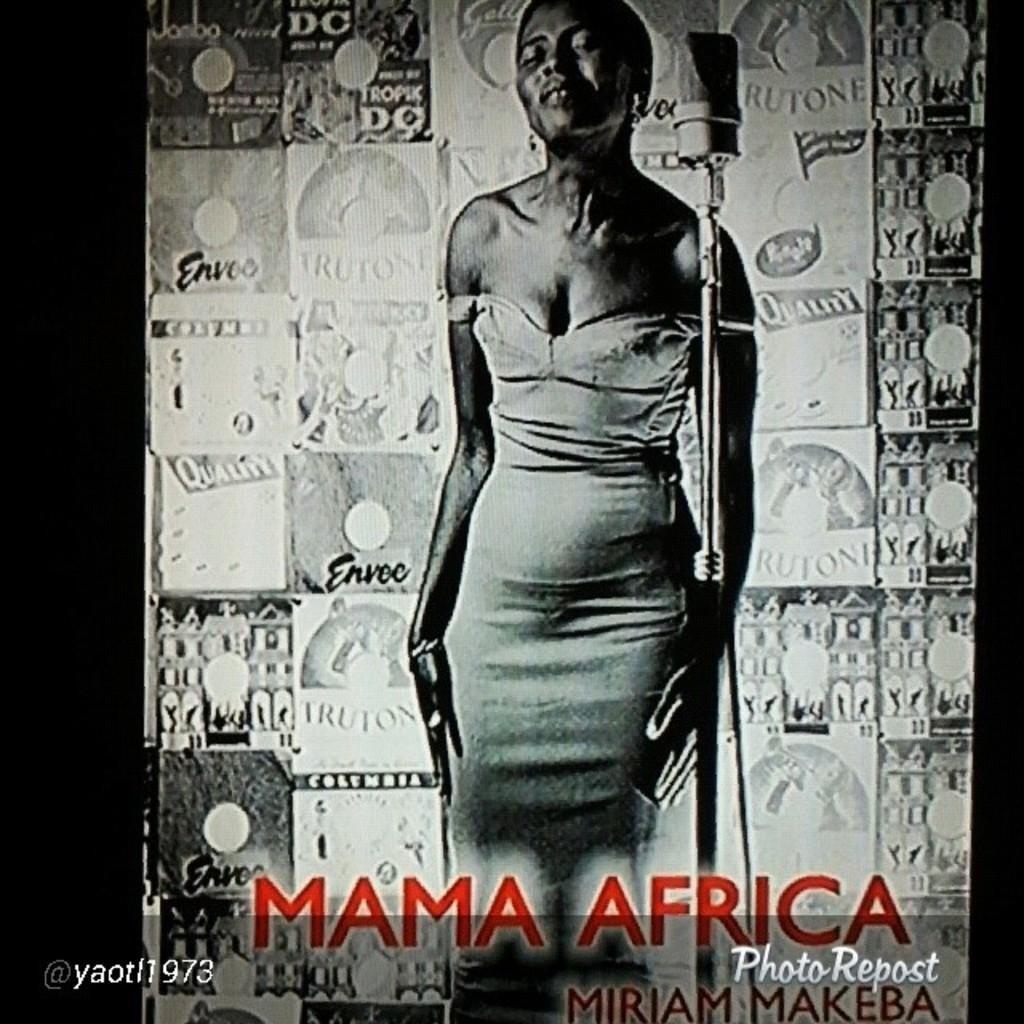In one or two sentences, can you explain what this image depicts? The picture is a poster. In the center of the picture there is a woman standing near a mic. In the background there is a banner. At the bottom there is text. 